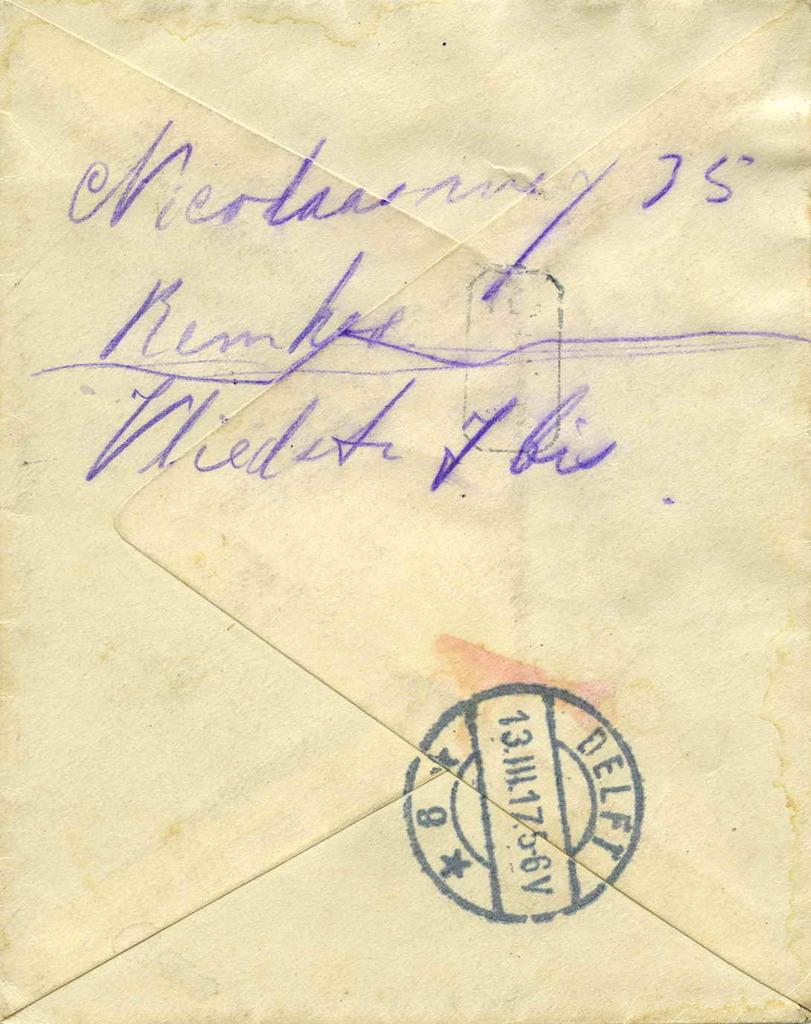What does the stamp say?
Provide a succinct answer. Delft. 